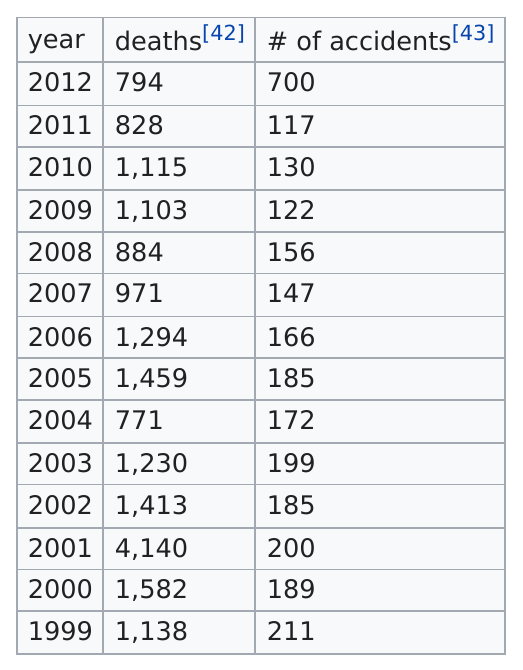Specify some key components in this picture. In the year 2012, there were 794 deaths resulting from plane accidents. The year 2001 was responsible for 4,140 deaths. There were 156 accidents in 2008, according to the plan. 